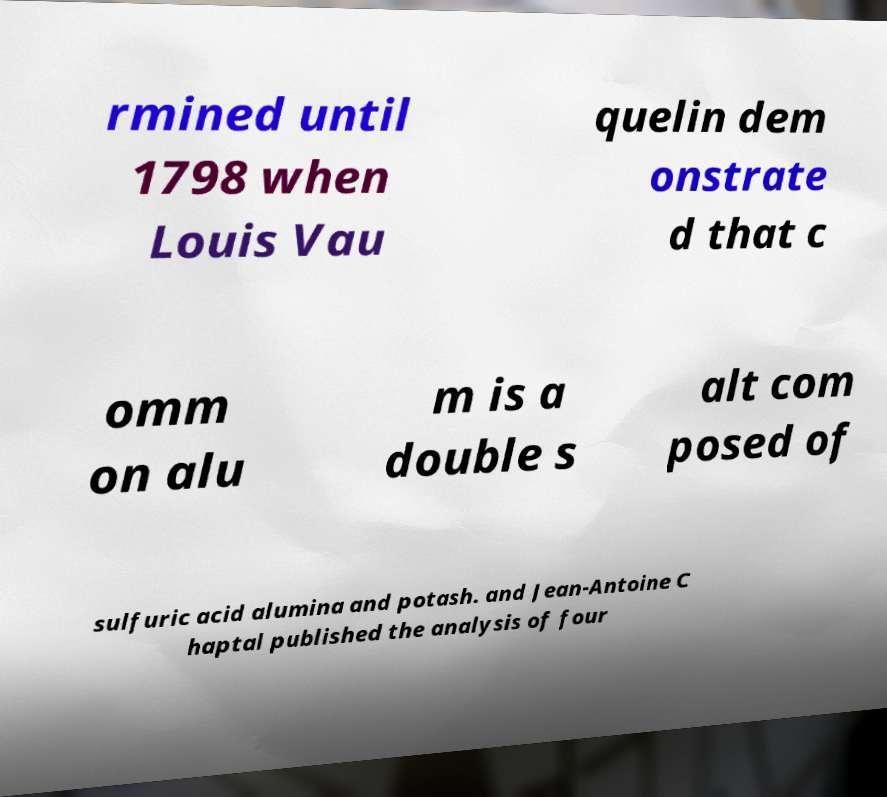For documentation purposes, I need the text within this image transcribed. Could you provide that? rmined until 1798 when Louis Vau quelin dem onstrate d that c omm on alu m is a double s alt com posed of sulfuric acid alumina and potash. and Jean-Antoine C haptal published the analysis of four 